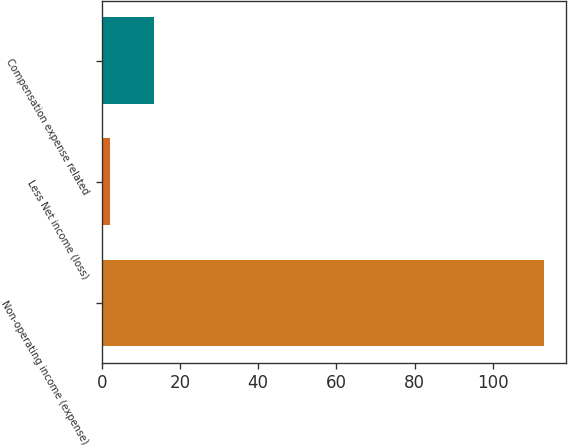Convert chart. <chart><loc_0><loc_0><loc_500><loc_500><bar_chart><fcel>Non-operating income (expense)<fcel>Less Net income (loss)<fcel>Compensation expense related<nl><fcel>113<fcel>2<fcel>13.4<nl></chart> 